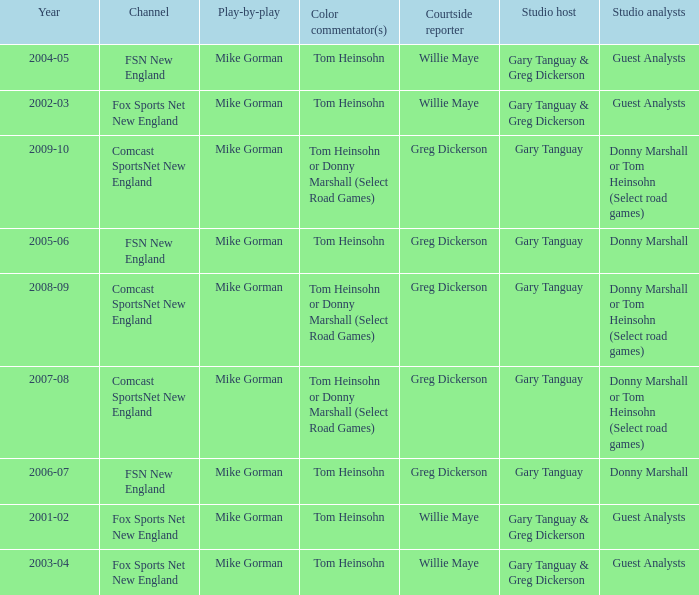How many channels were the games shown on in 2001-02? 1.0. 